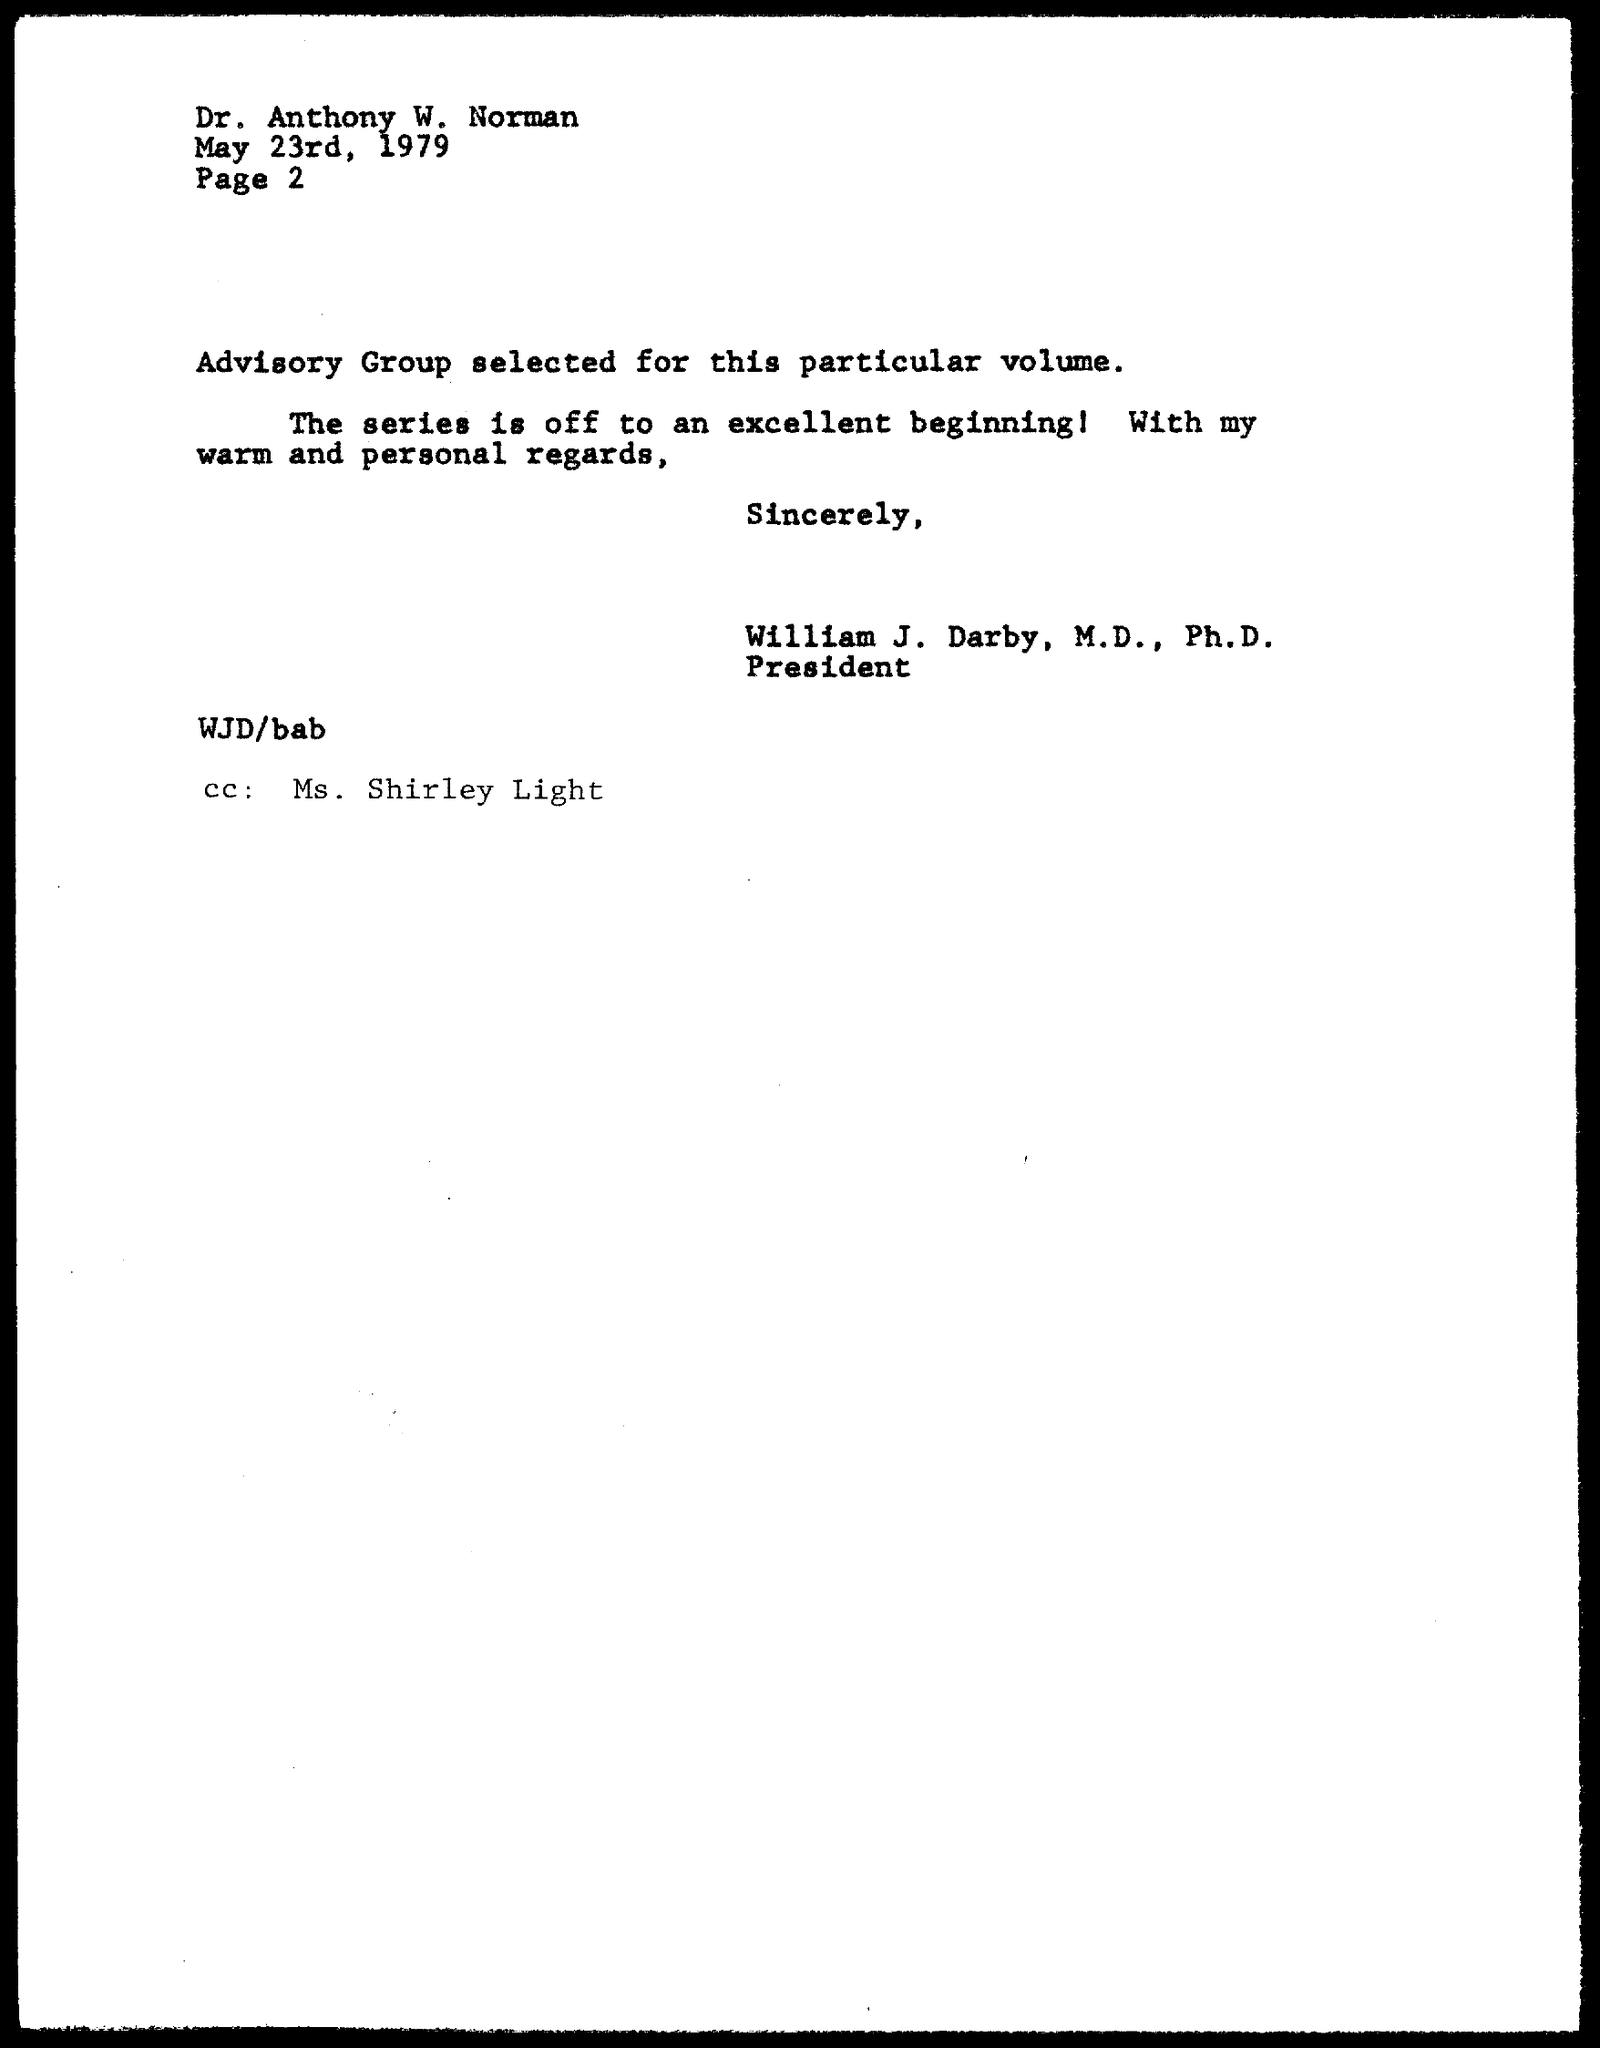When is the memorandum dated on ?
Offer a terse response. May 23rd, 1979. Who is the Memorandum Addressed to ?
Provide a short and direct response. DR. ANTHONY W. NORMAN. Who is the "CC" Address ?
Ensure brevity in your answer.  Ms. Shirley Light. 